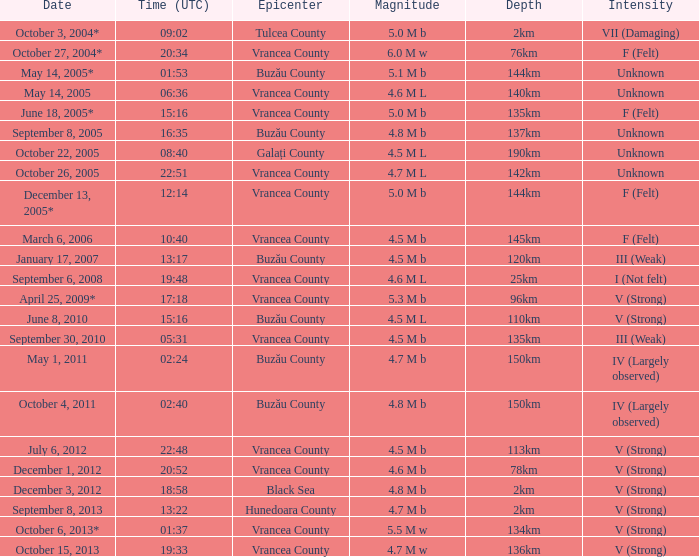What is the magnitude with epicenter at Vrancea County, unknown intensity and which happened at 06:36? 4.6 M L. 